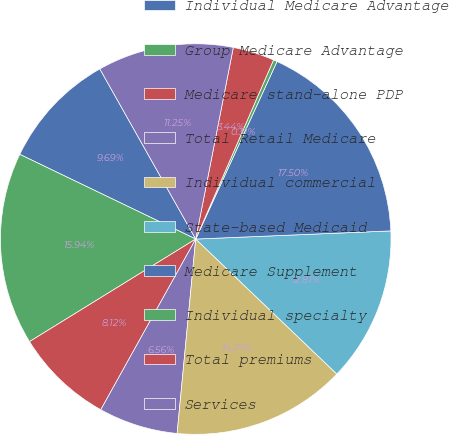Convert chart to OTSL. <chart><loc_0><loc_0><loc_500><loc_500><pie_chart><fcel>Individual Medicare Advantage<fcel>Group Medicare Advantage<fcel>Medicare stand-alone PDP<fcel>Total Retail Medicare<fcel>Individual commercial<fcel>State-based Medicaid<fcel>Medicare Supplement<fcel>Individual specialty<fcel>Total premiums<fcel>Services<nl><fcel>9.69%<fcel>15.94%<fcel>8.12%<fcel>6.56%<fcel>14.37%<fcel>12.81%<fcel>17.5%<fcel>0.31%<fcel>3.44%<fcel>11.25%<nl></chart> 